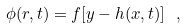Convert formula to latex. <formula><loc_0><loc_0><loc_500><loc_500>\phi ( { r } , t ) = f [ y - h ( { x } , t ) ] \ ,</formula> 